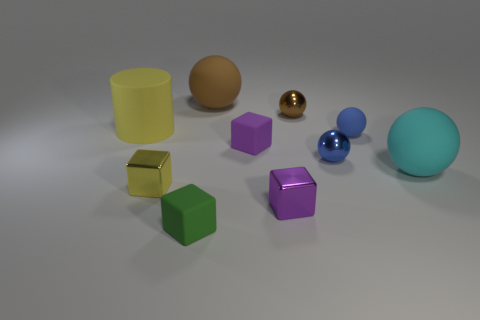What material is the yellow thing that is in front of the rubber cylinder?
Make the answer very short. Metal. What shape is the tiny metal thing behind the small rubber cube right of the tiny green rubber object in front of the small blue shiny object?
Your answer should be compact. Sphere. Does the metal object behind the large yellow matte cylinder have the same color as the large matte ball in front of the cylinder?
Ensure brevity in your answer.  No. Is the number of big matte spheres that are to the left of the yellow rubber thing less than the number of tiny metal blocks on the right side of the cyan object?
Ensure brevity in your answer.  No. Are there any other things that have the same shape as the cyan object?
Ensure brevity in your answer.  Yes. The other rubber object that is the same shape as the purple rubber object is what color?
Your answer should be very brief. Green. There is a green thing; is its shape the same as the large yellow matte thing that is behind the small yellow object?
Your answer should be very brief. No. What number of objects are either large objects behind the large cyan rubber sphere or big spheres on the left side of the cyan rubber object?
Offer a terse response. 2. What is the material of the big yellow thing?
Your answer should be compact. Rubber. How many other things are the same size as the yellow rubber object?
Ensure brevity in your answer.  2. 